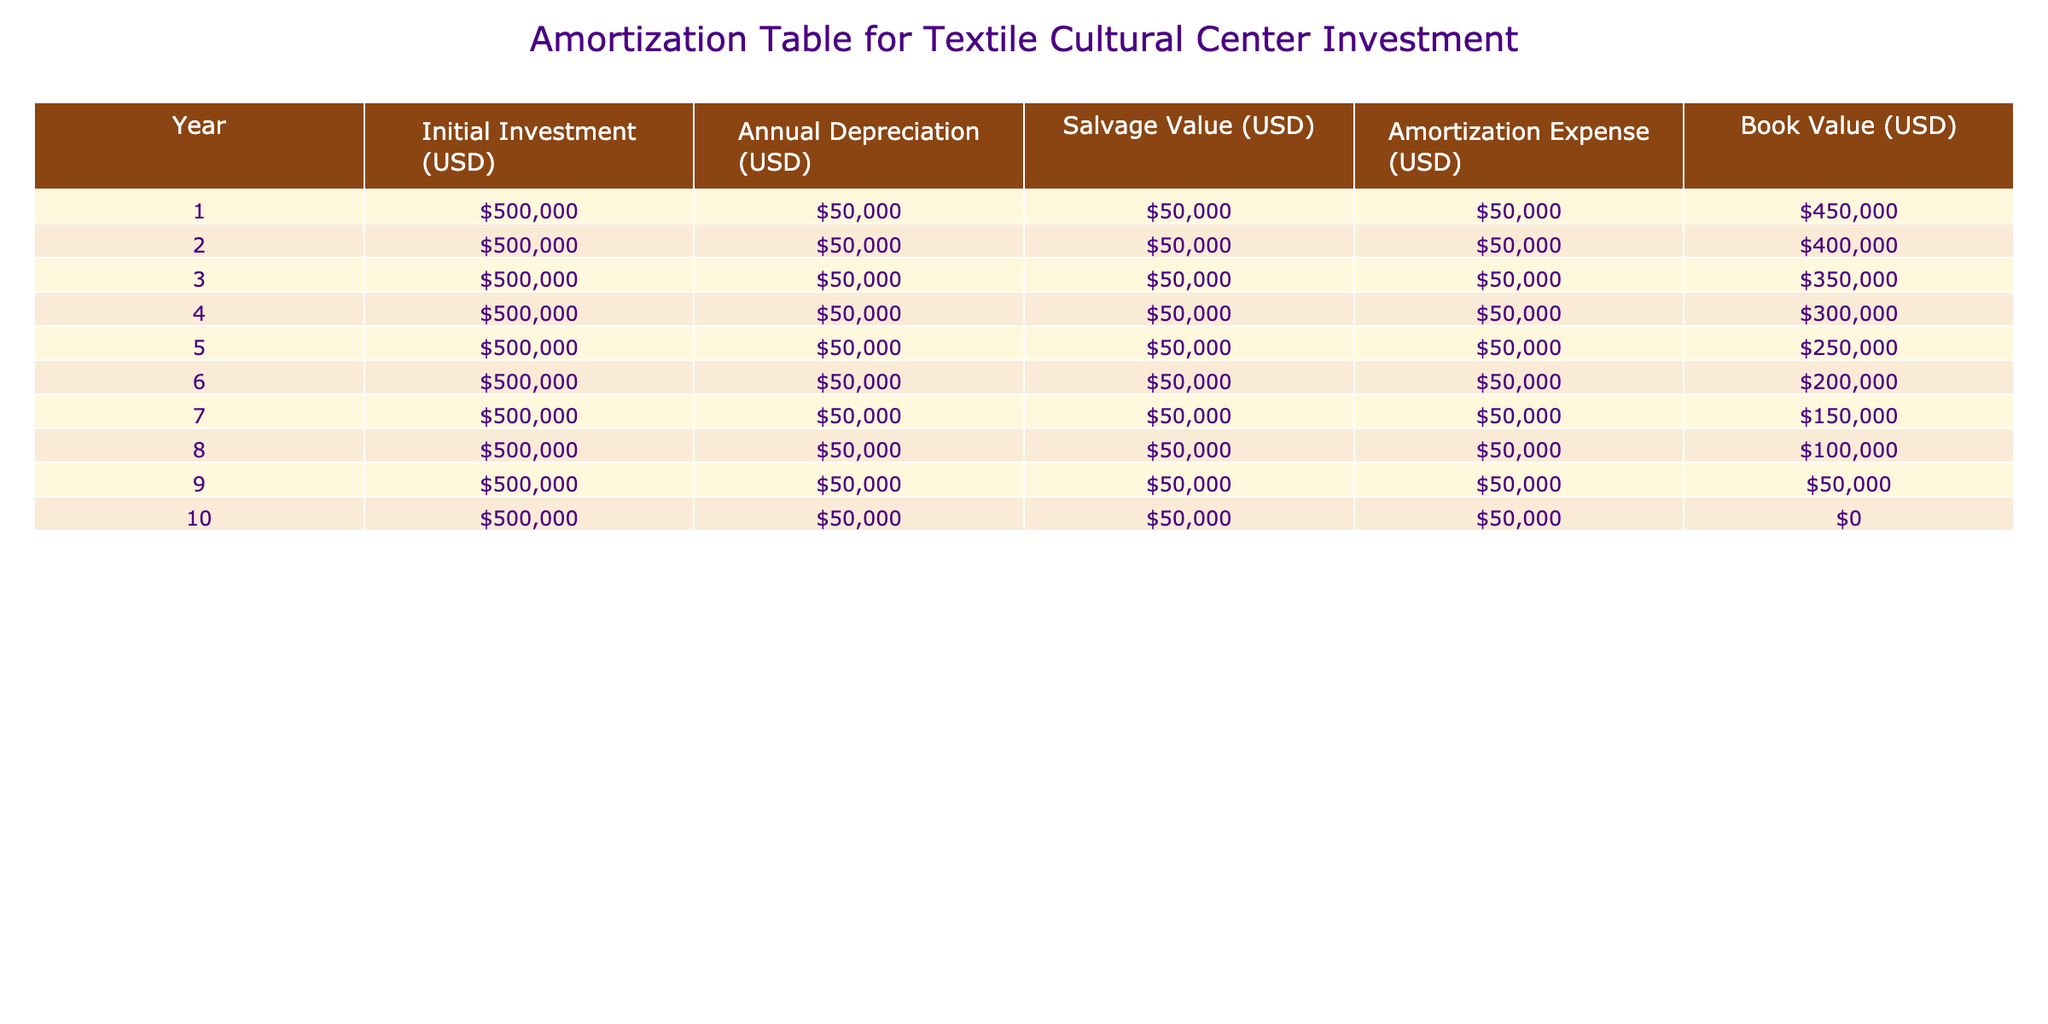What is the total initial investment over the 10 years? The initial investment for each year is constant at 500,000 USD. Over 10 years, the total initial investment is 500,000 USD multiplied by 10, which equals 5,000,000 USD.
Answer: 5,000,000 USD What is the amortization expense for the first year? The table shows that the amortization expense for the first year is listed directly under "Amortization Expense," which indicates it is 50,000 USD.
Answer: 50,000 USD Is the book value after 5 years higher than the salvage value? The book value after 5 years is 250,000 USD, and the salvage value is 50,000 USD. Since 250,000 is greater than 50,000, the statement is true.
Answer: Yes When does the book value reach zero? The book value reaches zero at the end of the 10th year as indicated in the last row of the table. The final value in the “Book Value” column for Year 10 is 0 USD.
Answer: Year 10 What is the difference in book value between year 1 and year 3? The book value in year 1 is 450,000 USD, and in year 3 it is 350,000 USD. The difference is 450,000 USD minus 350,000 USD, which equals 100,000 USD.
Answer: 100,000 USD What is the average annual amortization expense over the 10 years? The annual amortization expense is constant at 50,000 USD each year for the 10 years. Therefore, the average remains 50,000 USD as there’s no variation.
Answer: 50,000 USD In which year is the annual depreciation the same as the amortization expense? The annual depreciation is consistently set at 50,000 USD for all years, and this matches the amortization expense listed in the table for each year. Therefore, each year confirms this equality.
Answer: All years What is the cumulative depreciation by the end of year 6? The depreciation for each year is 50,000 USD. By year 6, the cumulative depreciation would be 6 multiplied by 50,000, which totals 300,000 USD.
Answer: 300,000 USD 